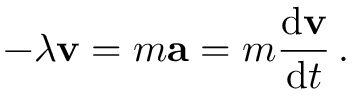<formula> <loc_0><loc_0><loc_500><loc_500>- \lambda v = m a = m { \frac { d v } { d t } } \, .</formula> 